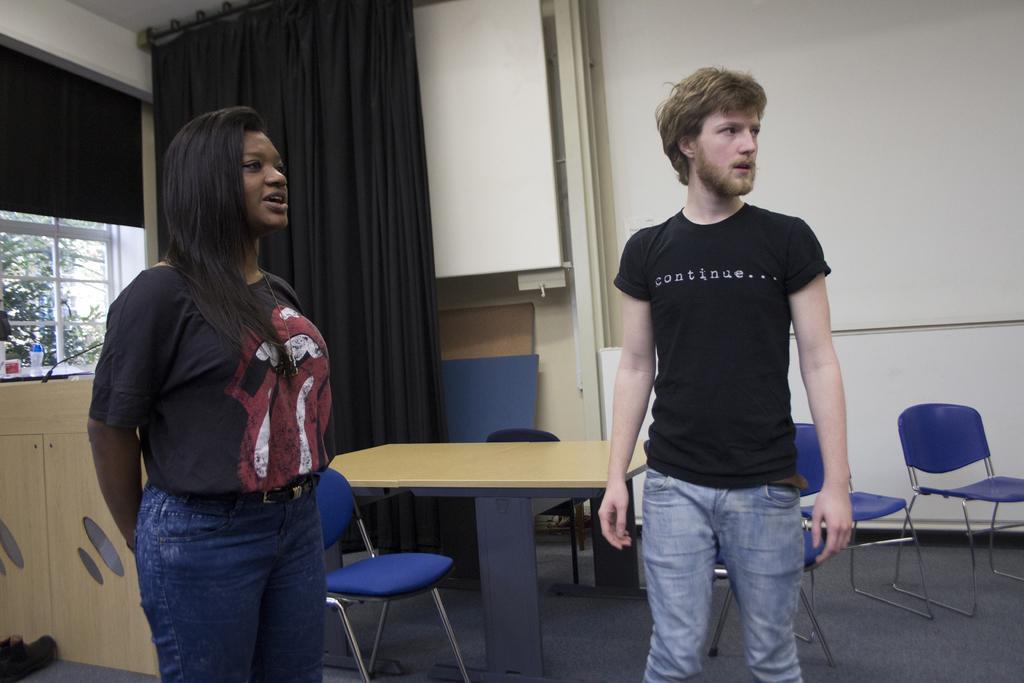Describe this image in one or two sentences. The image is inside the room. In the image there are two people man and women who are standing. On right side there is a white color wall and we can also see a table and few chairs, on left side we can see a black color curtain,window which is closed and a table. On table there are some bottle and a box, in background there is a tree and sky is on top. 